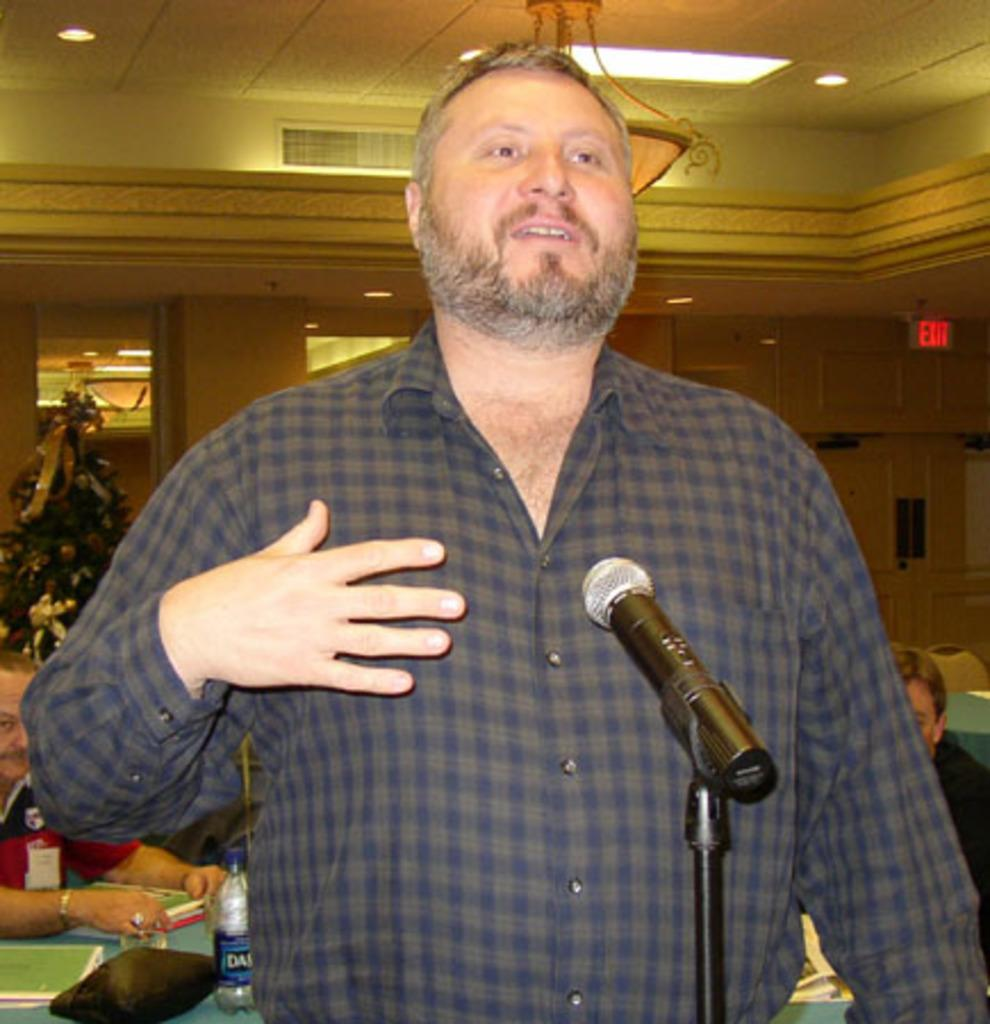Who is the main subject in the image? There is a man in the image. What is the man doing in the image? The man is talking in front of a mic. What can be seen in the background of the image? There is a Christmas tree, a pillar, lights, people sitting on chairs, a bottle, and books on a table in the background. What selection process is being used to choose the best books for the event in the image? There is no indication of a selection process or event in the image; it simply shows a man talking in front of a mic with various background elements. 